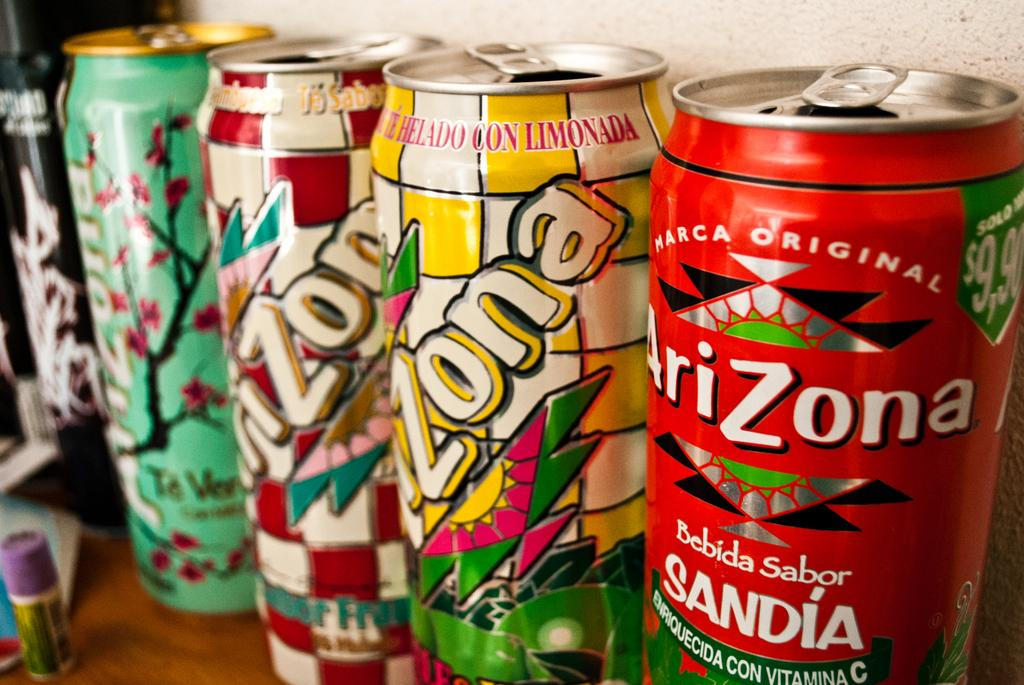<image>
Write a terse but informative summary of the picture. A collection of opened Arizona cans sit on a desk. 